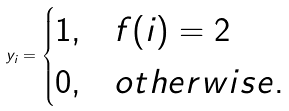Convert formula to latex. <formula><loc_0><loc_0><loc_500><loc_500>y _ { i } = \begin{cases} 1 , & f ( i ) = 2 \\ 0 , & o t h e r w i s e . \end{cases}</formula> 